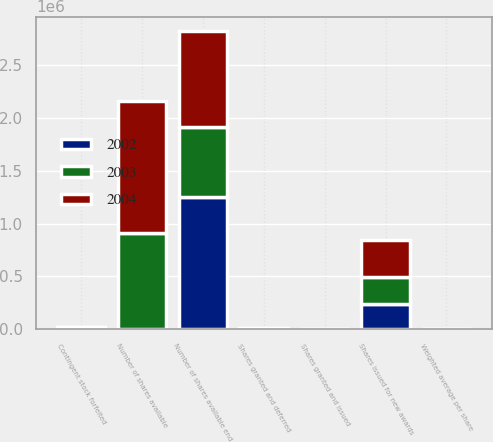Convert chart. <chart><loc_0><loc_0><loc_500><loc_500><stacked_bar_chart><ecel><fcel>Number of shares available<fcel>Shares issued for new awards<fcel>Contingent stock forfeited<fcel>Number of shares available end<fcel>Weighted average per share<fcel>Shares granted and issued<fcel>Shares granted and deferred<nl><fcel>2003<fcel>901195<fcel>252275<fcel>14400<fcel>663320<fcel>49.79<fcel>1827<fcel>4263<nl><fcel>2004<fcel>1.25135e+06<fcel>356705<fcel>6550<fcel>901195<fcel>43.09<fcel>2724<fcel>4767<nl><fcel>2002<fcel>6175<fcel>238900<fcel>5800<fcel>1.25135e+06<fcel>30.27<fcel>2605<fcel>5293<nl></chart> 